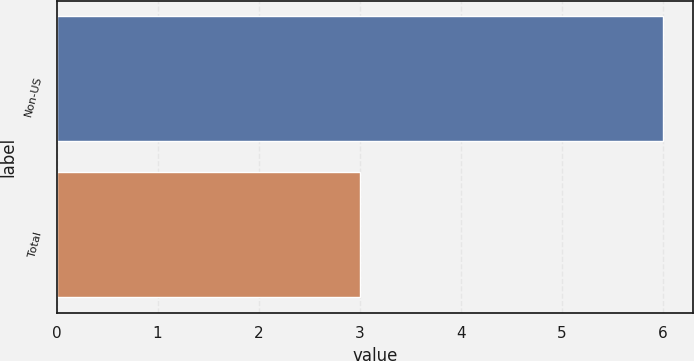Convert chart to OTSL. <chart><loc_0><loc_0><loc_500><loc_500><bar_chart><fcel>Non-US<fcel>Total<nl><fcel>6<fcel>3<nl></chart> 